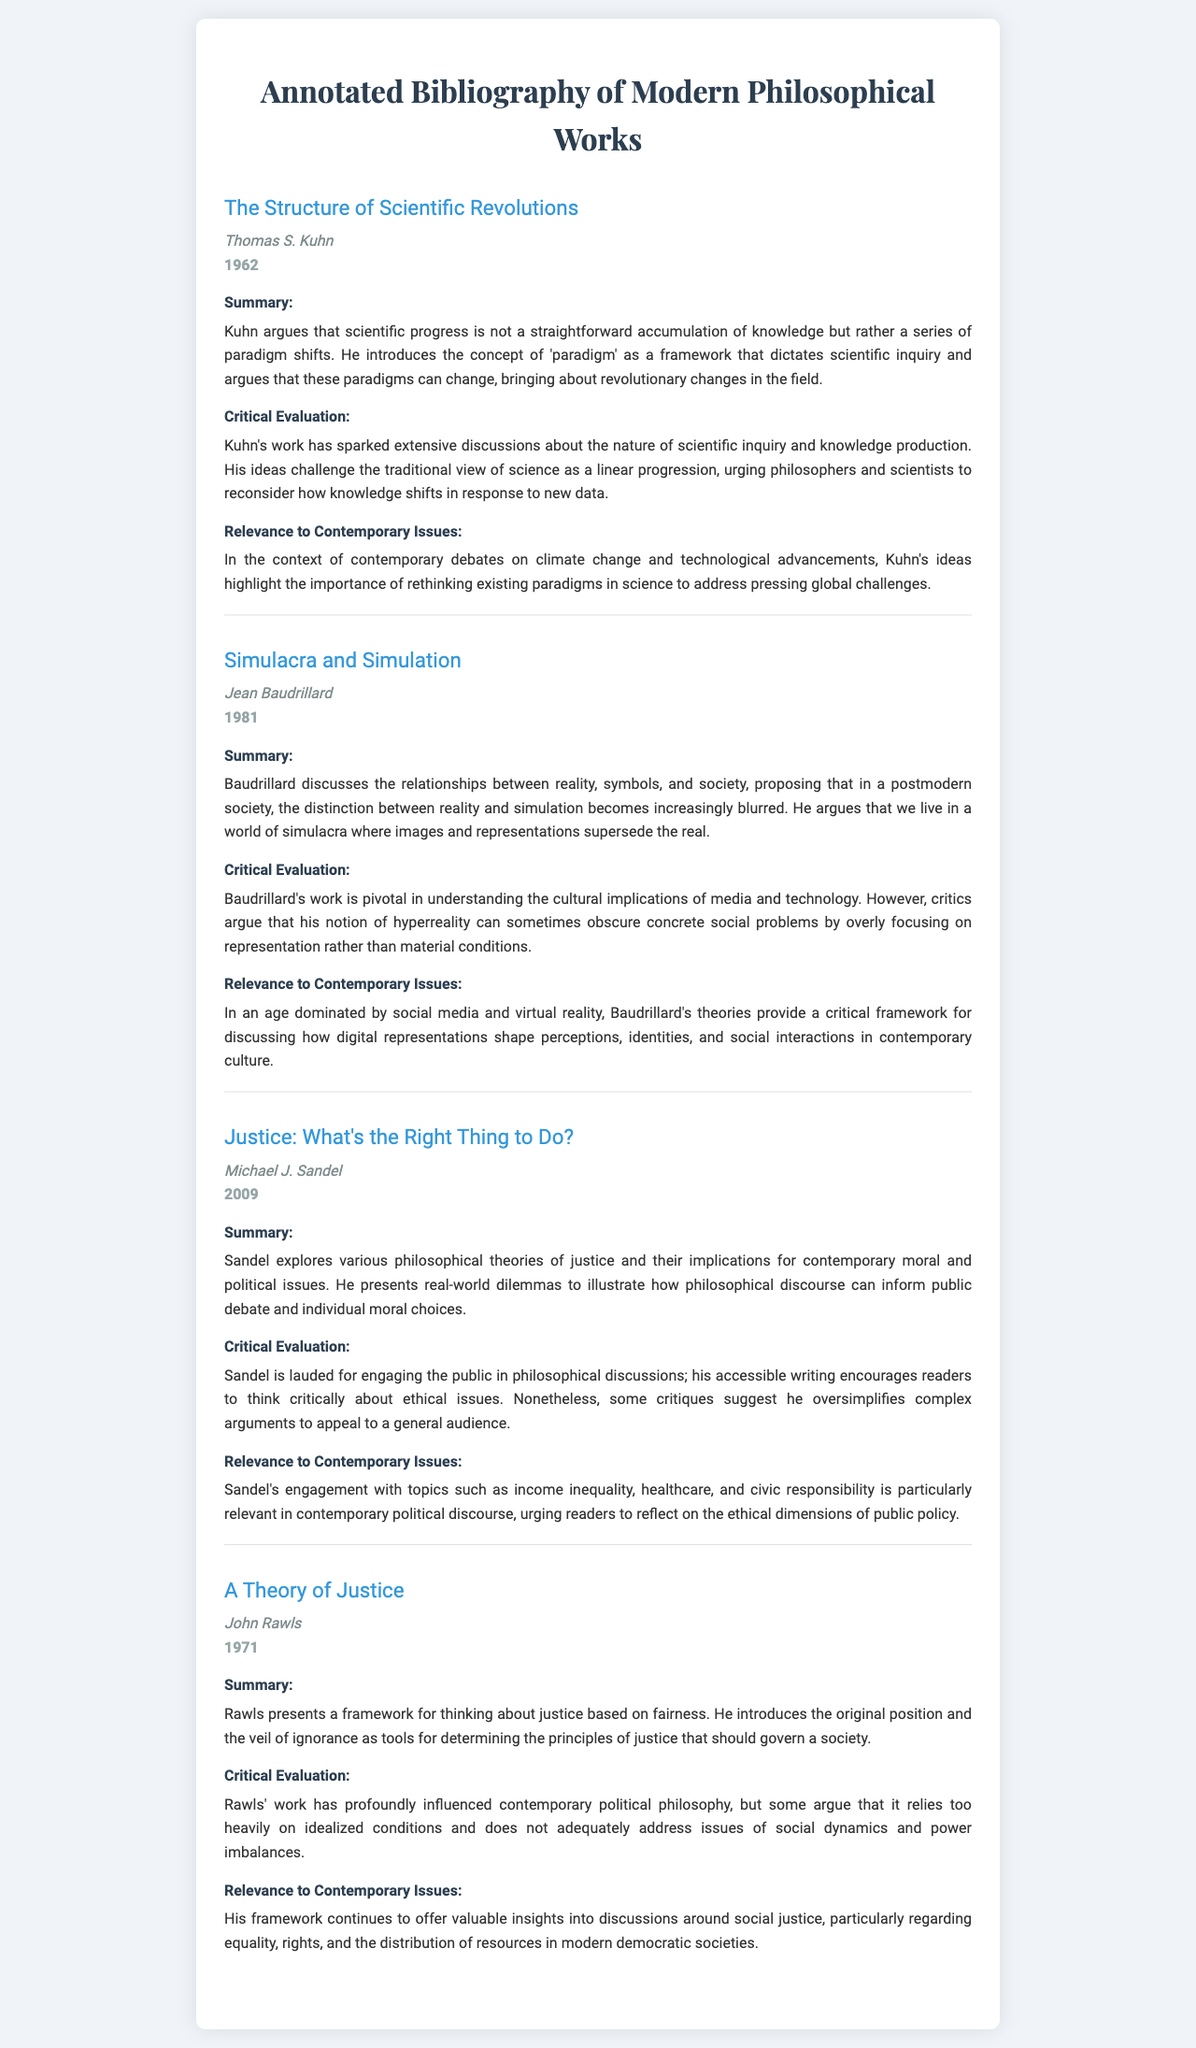what is the title of the first book listed? The title of the first book listed in the document is found in the relevant section under the book's information.
Answer: The Structure of Scientific Revolutions who is the author of "Justice: What's the Right Thing to Do?" The author of the book is specified right below the title.
Answer: Michael J. Sandel in what year was "Simulacra and Simulation" published? The publication year can be located next to the author's name in the document.
Answer: 1981 what concept does Kuhn introduce related to scientific progress? The document indicates this concept in the summary of Kuhn's work, relating to how knowledge is structured.
Answer: Paradigm which philosopher critiques the oversimplification of complex arguments? The relevant critique is mentioned in the critical evaluation section, attributing it to a specific philosopher.
Answer: Michael J. Sandel how does Rawls' work influence contemporary discussions? The relevance of Rawls’ influence is elaborated in the document's section dedicated to contemporary issues.
Answer: Social justice what is the main focus of Baudrillard's theory? The document provides insights into Baudrillard's central argument under the summary section.
Answer: Simulation which book discusses the veil of ignorance? The relevant book discussing this concept is highlighted in the summary portion of Rawls' work.
Answer: A Theory of Justice what revolutionizes the field of scientific inquiry according to Kuhn? This is explored in the critical evaluation section concerning Kuhn's contributions.
Answer: Paradigm shifts 